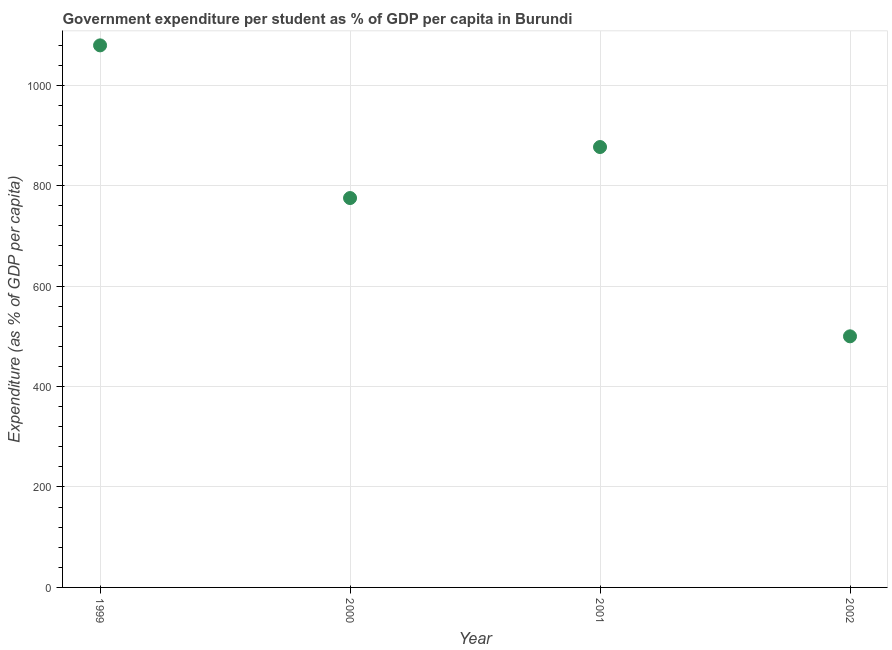What is the government expenditure per student in 2002?
Offer a very short reply. 499.95. Across all years, what is the maximum government expenditure per student?
Offer a terse response. 1079.27. Across all years, what is the minimum government expenditure per student?
Your response must be concise. 499.95. In which year was the government expenditure per student maximum?
Your answer should be compact. 1999. What is the sum of the government expenditure per student?
Offer a very short reply. 3231.37. What is the difference between the government expenditure per student in 2001 and 2002?
Your answer should be very brief. 376.92. What is the average government expenditure per student per year?
Make the answer very short. 807.84. What is the median government expenditure per student?
Ensure brevity in your answer.  826.07. In how many years, is the government expenditure per student greater than 80 %?
Your answer should be compact. 4. Do a majority of the years between 2002 and 2001 (inclusive) have government expenditure per student greater than 120 %?
Offer a very short reply. No. What is the ratio of the government expenditure per student in 2001 to that in 2002?
Keep it short and to the point. 1.75. Is the difference between the government expenditure per student in 1999 and 2001 greater than the difference between any two years?
Provide a succinct answer. No. What is the difference between the highest and the second highest government expenditure per student?
Ensure brevity in your answer.  202.39. Is the sum of the government expenditure per student in 2000 and 2001 greater than the maximum government expenditure per student across all years?
Your response must be concise. Yes. What is the difference between the highest and the lowest government expenditure per student?
Give a very brief answer. 579.31. In how many years, is the government expenditure per student greater than the average government expenditure per student taken over all years?
Offer a terse response. 2. How many dotlines are there?
Offer a terse response. 1. How many years are there in the graph?
Ensure brevity in your answer.  4. Are the values on the major ticks of Y-axis written in scientific E-notation?
Make the answer very short. No. Does the graph contain any zero values?
Ensure brevity in your answer.  No. What is the title of the graph?
Provide a succinct answer. Government expenditure per student as % of GDP per capita in Burundi. What is the label or title of the X-axis?
Give a very brief answer. Year. What is the label or title of the Y-axis?
Your response must be concise. Expenditure (as % of GDP per capita). What is the Expenditure (as % of GDP per capita) in 1999?
Make the answer very short. 1079.27. What is the Expenditure (as % of GDP per capita) in 2000?
Keep it short and to the point. 775.27. What is the Expenditure (as % of GDP per capita) in 2001?
Your response must be concise. 876.87. What is the Expenditure (as % of GDP per capita) in 2002?
Make the answer very short. 499.95. What is the difference between the Expenditure (as % of GDP per capita) in 1999 and 2000?
Keep it short and to the point. 303.99. What is the difference between the Expenditure (as % of GDP per capita) in 1999 and 2001?
Give a very brief answer. 202.39. What is the difference between the Expenditure (as % of GDP per capita) in 1999 and 2002?
Make the answer very short. 579.31. What is the difference between the Expenditure (as % of GDP per capita) in 2000 and 2001?
Your answer should be compact. -101.6. What is the difference between the Expenditure (as % of GDP per capita) in 2000 and 2002?
Offer a terse response. 275.32. What is the difference between the Expenditure (as % of GDP per capita) in 2001 and 2002?
Provide a short and direct response. 376.92. What is the ratio of the Expenditure (as % of GDP per capita) in 1999 to that in 2000?
Your answer should be very brief. 1.39. What is the ratio of the Expenditure (as % of GDP per capita) in 1999 to that in 2001?
Keep it short and to the point. 1.23. What is the ratio of the Expenditure (as % of GDP per capita) in 1999 to that in 2002?
Your response must be concise. 2.16. What is the ratio of the Expenditure (as % of GDP per capita) in 2000 to that in 2001?
Keep it short and to the point. 0.88. What is the ratio of the Expenditure (as % of GDP per capita) in 2000 to that in 2002?
Keep it short and to the point. 1.55. What is the ratio of the Expenditure (as % of GDP per capita) in 2001 to that in 2002?
Offer a terse response. 1.75. 